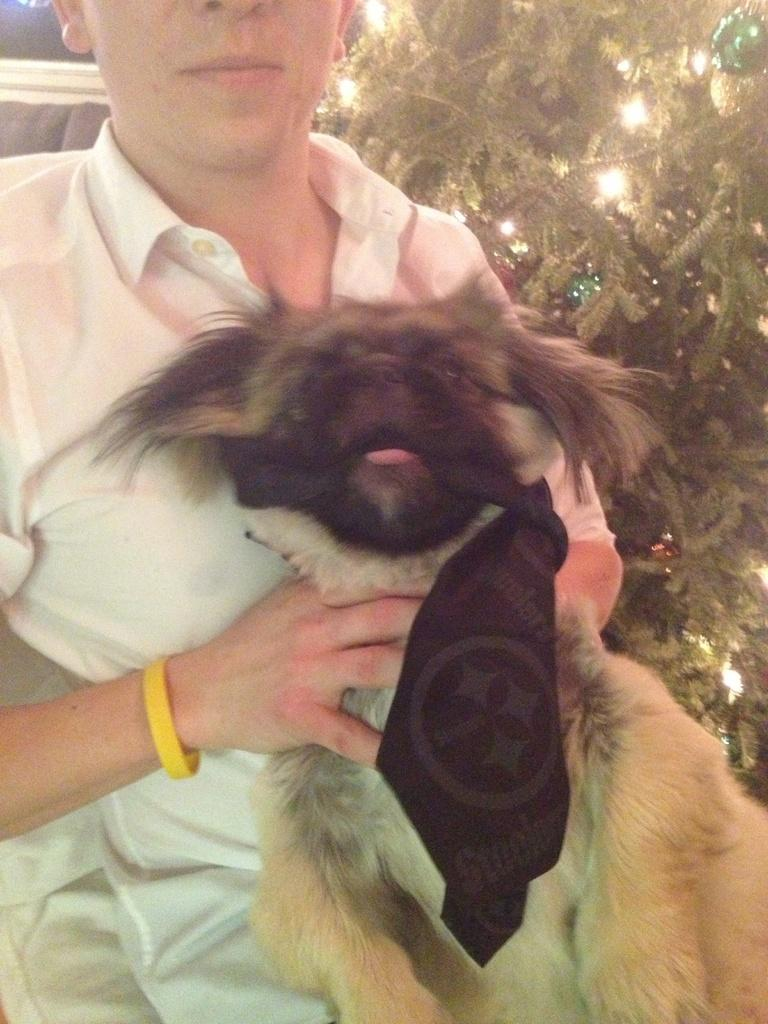What is happening in the image? There is a person in the image holding a dog. Can you describe the person in the image? The person is holding a dog, but we cannot see any specific details about their appearance. What else can be seen in the background of the image? There is a plant in the background of the image. What type of industry is depicted in the image? There is no industry present in the image; it features a person holding a dog and a plant in the background. What color are the person's teeth in the image? There is no information about the person's teeth in the image, as their mouth is not visible. 